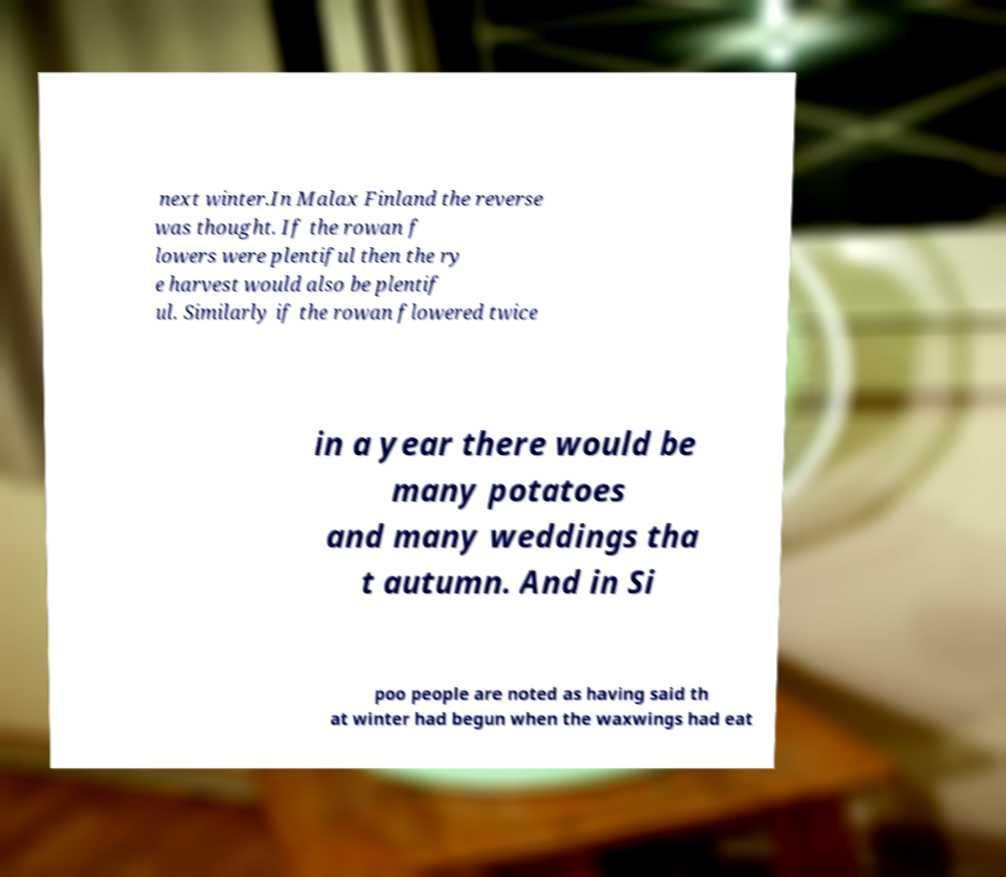Please read and relay the text visible in this image. What does it say? next winter.In Malax Finland the reverse was thought. If the rowan f lowers were plentiful then the ry e harvest would also be plentif ul. Similarly if the rowan flowered twice in a year there would be many potatoes and many weddings tha t autumn. And in Si poo people are noted as having said th at winter had begun when the waxwings had eat 